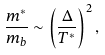<formula> <loc_0><loc_0><loc_500><loc_500>\frac { m ^ { * } } { m _ { b } } \sim \left ( \frac { \Delta } { T ^ { * } } \right ) ^ { 2 } ,</formula> 